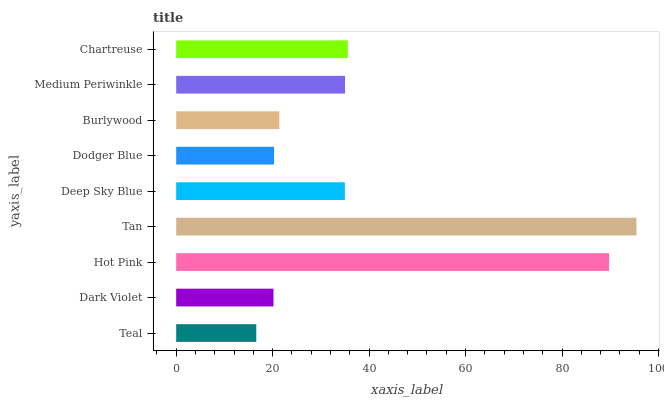Is Teal the minimum?
Answer yes or no. Yes. Is Tan the maximum?
Answer yes or no. Yes. Is Dark Violet the minimum?
Answer yes or no. No. Is Dark Violet the maximum?
Answer yes or no. No. Is Dark Violet greater than Teal?
Answer yes or no. Yes. Is Teal less than Dark Violet?
Answer yes or no. Yes. Is Teal greater than Dark Violet?
Answer yes or no. No. Is Dark Violet less than Teal?
Answer yes or no. No. Is Deep Sky Blue the high median?
Answer yes or no. Yes. Is Deep Sky Blue the low median?
Answer yes or no. Yes. Is Burlywood the high median?
Answer yes or no. No. Is Dark Violet the low median?
Answer yes or no. No. 